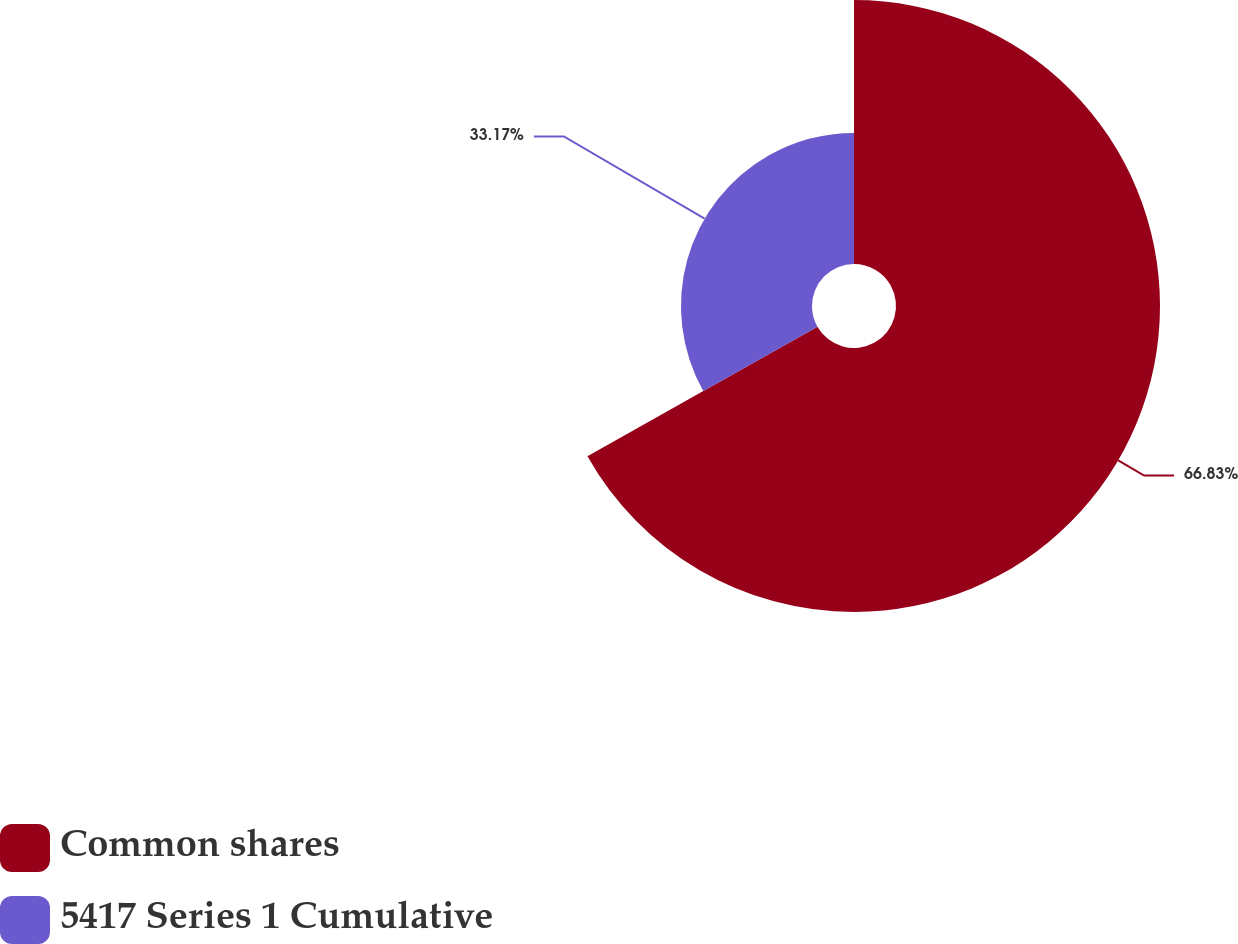<chart> <loc_0><loc_0><loc_500><loc_500><pie_chart><fcel>Common shares<fcel>5417 Series 1 Cumulative<nl><fcel>66.83%<fcel>33.17%<nl></chart> 